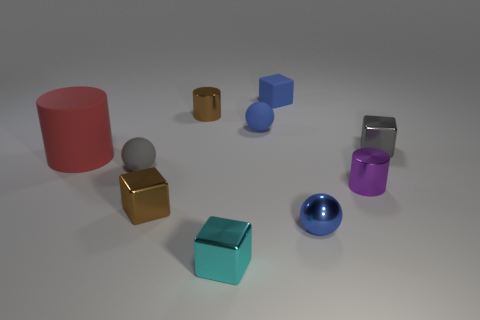Subtract all blue spheres. Subtract all red cylinders. How many spheres are left? 1 Subtract all cubes. How many objects are left? 6 Subtract all brown matte cylinders. Subtract all big red matte things. How many objects are left? 9 Add 1 tiny blue cubes. How many tiny blue cubes are left? 2 Add 6 cyan metallic blocks. How many cyan metallic blocks exist? 7 Subtract 0 purple cubes. How many objects are left? 10 